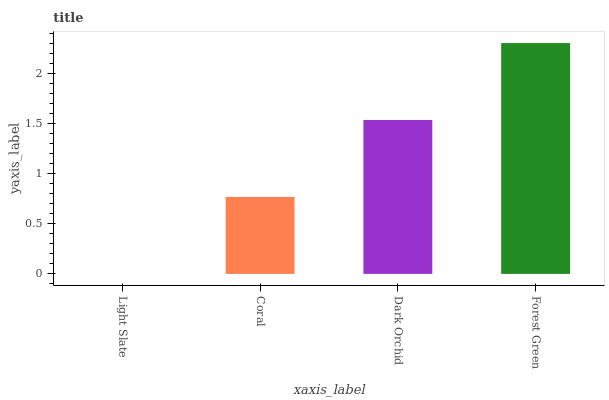Is Coral the minimum?
Answer yes or no. No. Is Coral the maximum?
Answer yes or no. No. Is Coral greater than Light Slate?
Answer yes or no. Yes. Is Light Slate less than Coral?
Answer yes or no. Yes. Is Light Slate greater than Coral?
Answer yes or no. No. Is Coral less than Light Slate?
Answer yes or no. No. Is Dark Orchid the high median?
Answer yes or no. Yes. Is Coral the low median?
Answer yes or no. Yes. Is Coral the high median?
Answer yes or no. No. Is Light Slate the low median?
Answer yes or no. No. 